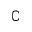Convert formula to latex. <formula><loc_0><loc_0><loc_500><loc_500>\complement</formula> 